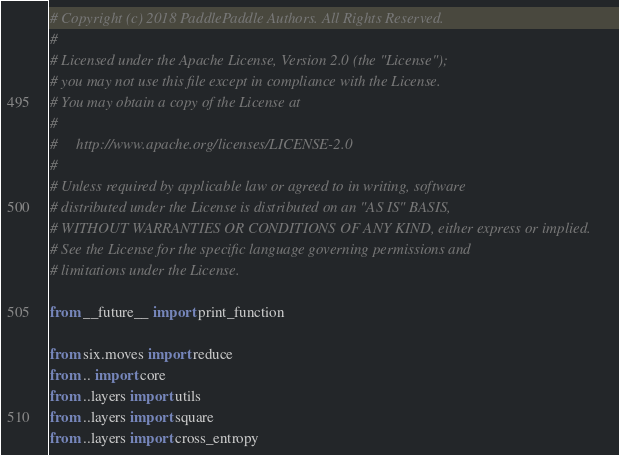<code> <loc_0><loc_0><loc_500><loc_500><_Python_># Copyright (c) 2018 PaddlePaddle Authors. All Rights Reserved.
#
# Licensed under the Apache License, Version 2.0 (the "License");
# you may not use this file except in compliance with the License.
# You may obtain a copy of the License at
#
#     http://www.apache.org/licenses/LICENSE-2.0
#
# Unless required by applicable law or agreed to in writing, software
# distributed under the License is distributed on an "AS IS" BASIS,
# WITHOUT WARRANTIES OR CONDITIONS OF ANY KIND, either express or implied.
# See the License for the specific language governing permissions and
# limitations under the License.

from __future__ import print_function

from six.moves import reduce
from .. import core
from ..layers import utils
from ..layers import square
from ..layers import cross_entropy</code> 